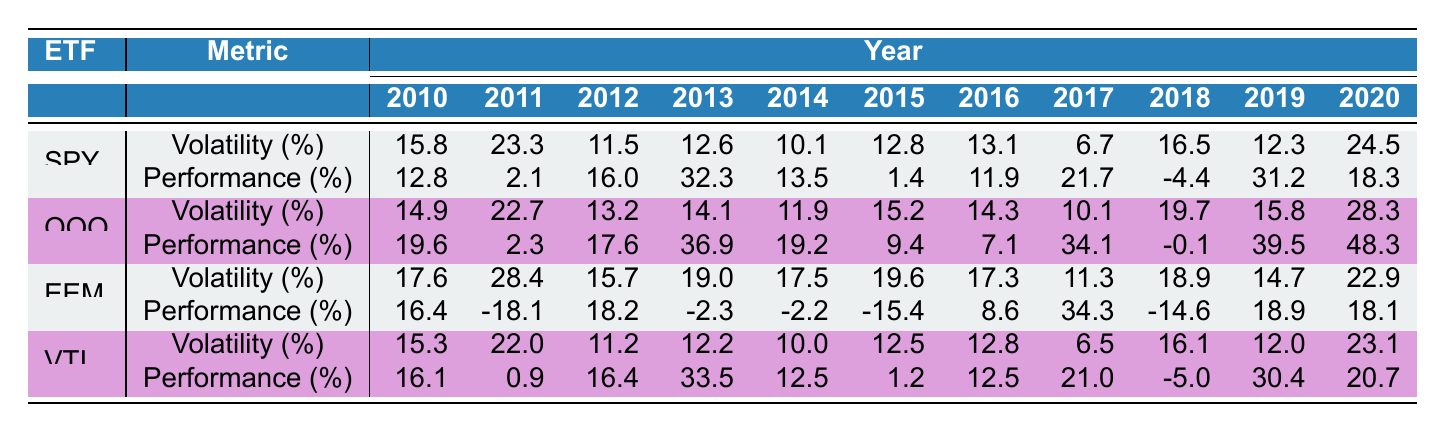What was the highest performance year for the SPDR S&P 500 ETF Trust? The highest performance for SPY occurred in 2013, with a value of 32.3%. Looking at the "Performance" values for SPY, 2013 stands out as the year with the highest figure.
Answer: 32.3% Which ETF had the highest average volatility from 2010 to 2020? To calculate the average volatility for each ETF, we sum the volatility values over the years and divide by the number of years. For EEM, the sum is 17.6 + 28.4 + 15.7 + 19.0 + 17.5 + 19.6 + 17.3 + 11.3 + 18.9 + 14.7 + 22.9 =  250.4 and divided by 11 equals approximately 22.76%. For SPY, the average is (15.8 + 23.3 + 11.5 + 12.6 + 10.1 + 12.8 + 13.1 + 6.7 + 16.5 + 12.3 + 24.5)/11 = 15.79%, and similarly calculated for QQQ and VTI. After performing these calculations, EEM has the highest average at approximately 22.76%.
Answer: EEM Did the Invesco QQQ Trust have any positive performance years between 2010 and 2020? A review of the performance figures for QQQ shows that every year between 2010 and 2020 had a positive performance rate, confirming that none of the years displayed negative performance.
Answer: Yes What was the difference in performance between the Vanguard Total Stock Market ETF and the iShares MSCI Emerging Markets ETF in 2018? The performance for VTI in 2018 was -5.0%, and for EEM, it was -14.6%. The difference is calculated by subtracting the performance of EEM from VTI: -5.0 - (-14.6) = 9.6%. Thus, VTI outperformed EEM by 9.6 percentage points in 2018.
Answer: 9.6% Which ETF experienced the lowest performance in any year from 2010 to 2020 and in what year did this occur? By evaluating the performance data across all ETFs, it is evident that EEM had the lowest performance in 2011 with a -18.1% return, which is the lowest in the entire dataset.
Answer: EEM in 2011 Which ETF had consistent performance above 10% for the most years? Analyzing the performance data, we count the years with performance above 10% for each ETF. SPY had 7 years and QQQ had 9 years above that threshold, while VTI had 6 years. Thus QQQ had the highest count with 9 years where performance was above 10%.
Answer: QQQ What was the average performance of the iShares MSCI Emerging Markets ETF over the entire period? The average performance for EEM is calculated by summing the yearly performance values and dividing by 11: (-18.1 + 16.4 + 18.2 - 2.3 - 2.2 - 15.4 + 8.6 + 34.3 - 14.6 + 18.9 + 18.1) / 11 = approx 1.3%. This shows that EEM had very close to neutral performance when averaged out.
Answer: 1.3% 